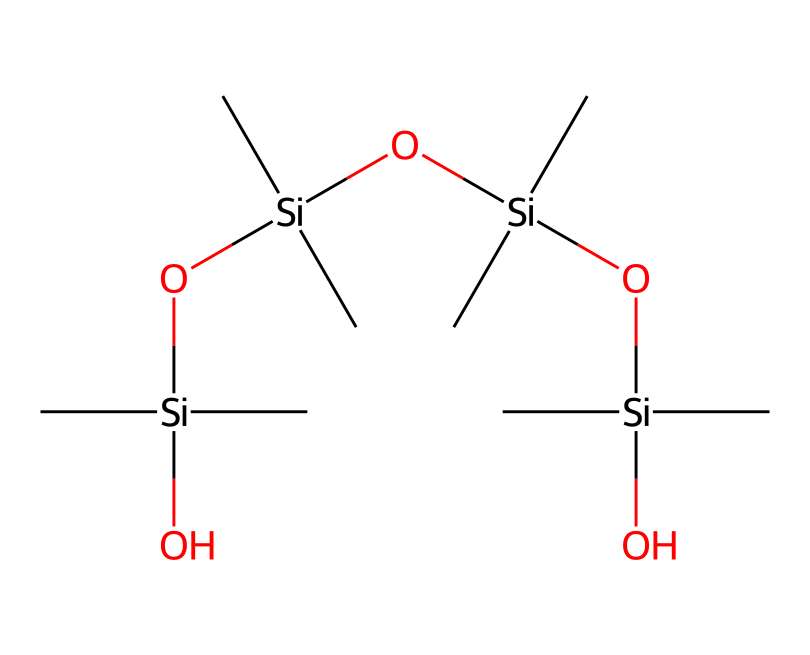What is the backbone structure of this lubricant? The backbone of this lubricant's structure is made up of silicon atoms connected by oxygen atoms, forming a siloxane chain. This can be observed from the repeating units of Si and O in the SMILES representation.
Answer: siloxane How many silicon atoms are present in the chemical? By inspecting the SMILES representation, there are four silicon atoms (Si) listed, indicating the presence of four silicon atoms in the lubricant structure.
Answer: four What functional groups are present in the lubricant? The functional groups in this lubricant mainly include silanol (-Si-OH) groups which indicate the presence of hydroxyl but since the structure focuses on siloxane, it's primarily a siloxane with terminal hydroxyls.
Answer: silanol What is the molecular arrangement of the lubricant? The lubricant features a branched silicon structure where each silicon atom has two methyl (C) groups attached and is linked through oxygen atoms. This branched arrangement provides flexibility and lubricating properties.
Answer: branched silicon Does this lubricant feature any hydrophilic properties? Yes, the presence of terminal silanol groups suggests that it has hydrophilic characteristics due to the ability to form hydrogen bonds with water, aiding in moisture retention on the turf.
Answer: yes What might be the primary application of this chemical in football pitch maintenance? Given its lubricating properties and ability to interact positively with moisture, this lubricant is used to enhance the playability and maintenance of grass surfaces, ensuring they remain hydrated and resilient.
Answer: turf maintenance 